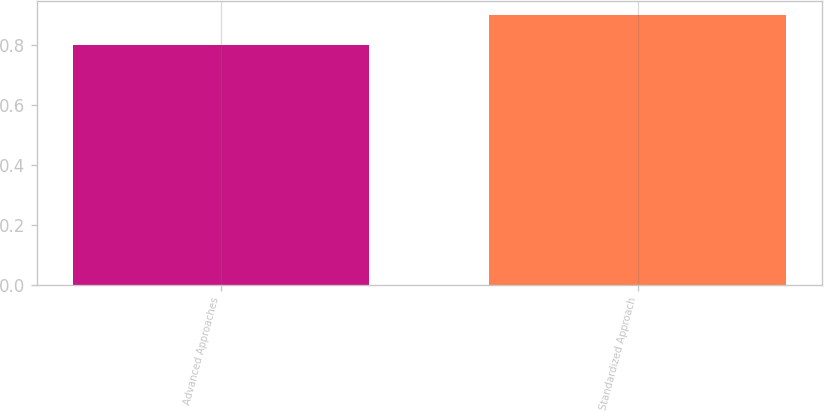<chart> <loc_0><loc_0><loc_500><loc_500><bar_chart><fcel>Advanced Approaches<fcel>Standardized Approach<nl><fcel>0.8<fcel>0.9<nl></chart> 